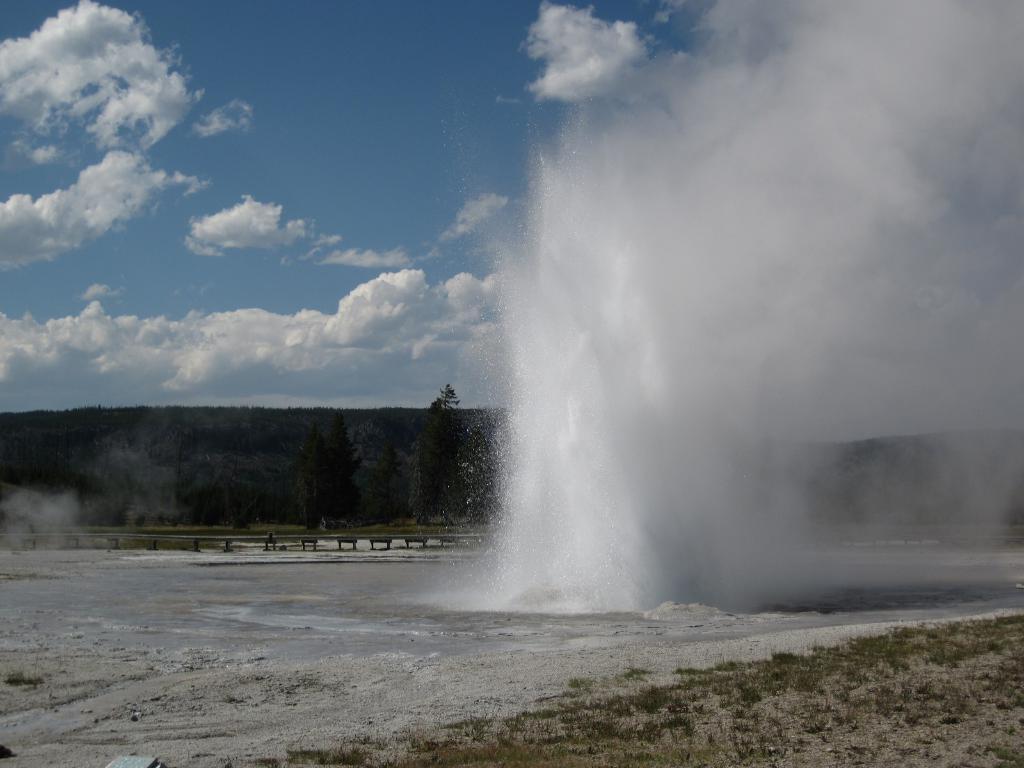How would you summarize this image in a sentence or two? At the bottom of the image there is grass and water. At the top of the image there are some trees and hills and clouds and sky. 